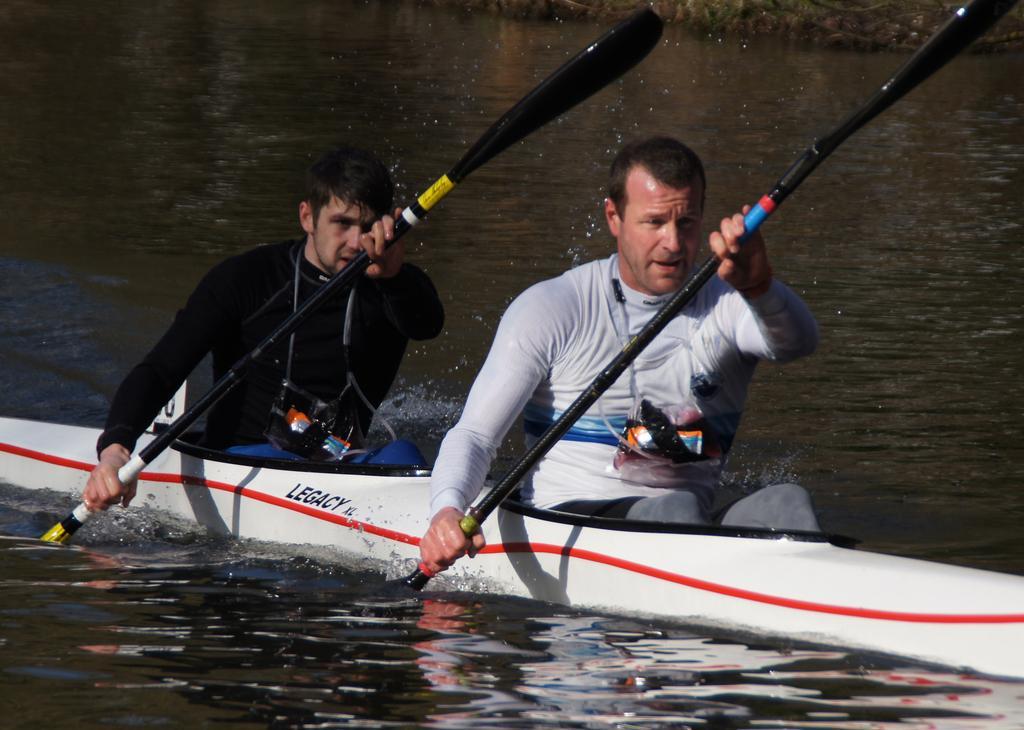Please provide a concise description of this image. In the center of the image there is a boat and we can see two people sitting in the boat and they are holding rows in their hands. At the bottom there is water. 